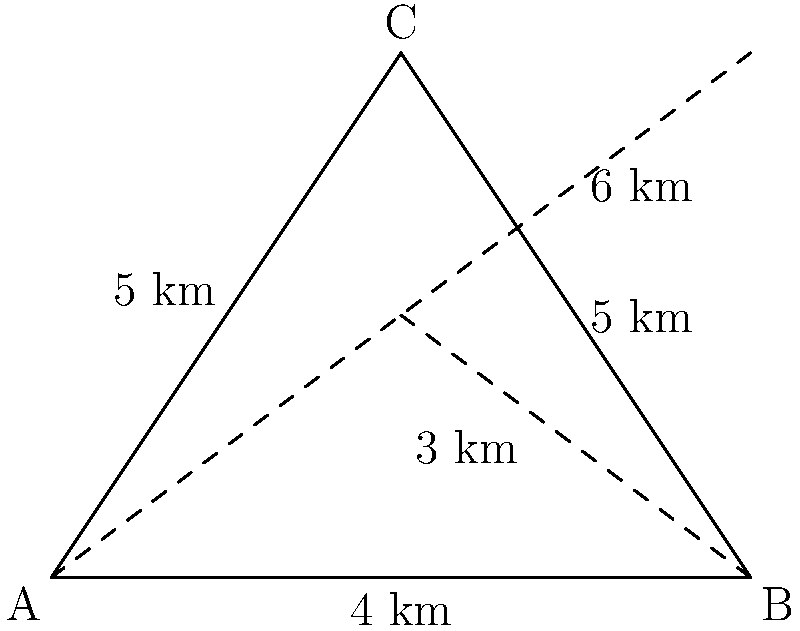A farmer needs to plow a triangular field ABC with sides of 4 km, 5 km, and 5 km. The tractor can move along the edges or cut across the field diagonally. If the tractor starts at point A and must cover all sides of the field, what is the minimum distance it needs to travel to complete the task and return to point A? Let's approach this step-by-step:

1) First, we need to understand that the tractor must cover all sides of the field. This means it must travel at least 4 + 5 + 5 = 14 km.

2) The question is whether cutting across the field diagonally at any point can reduce the total distance.

3) We can see from the diagram that there's a dashed line from B to the midpoint of AC. This creates two right-angled triangles.

4) In the right triangle with hypotenuse BC:
   $BC^2 = 5^2 = 25$
   $BD^2 + DC^2 = 4^2 + 3^2 = 16 + 9 = 25$
   So, BD (the dashed line from B) is 3 km and DC is 4 km.

5) Now, let's consider possible paths:
   Path 1: A → B → C → A = 4 + 5 + 5 = 14 km
   Path 2: A → C → B → A = 5 + 5 + 4 = 14 km
   Path 3: A → B → (diagonal) → C → A = 4 + 3 + 5 = 12 km

6) Path 3 is the shortest, covering all sides and using the diagonal to reduce total distance.

Therefore, the minimum distance the tractor needs to travel is 12 km.
Answer: 12 km 